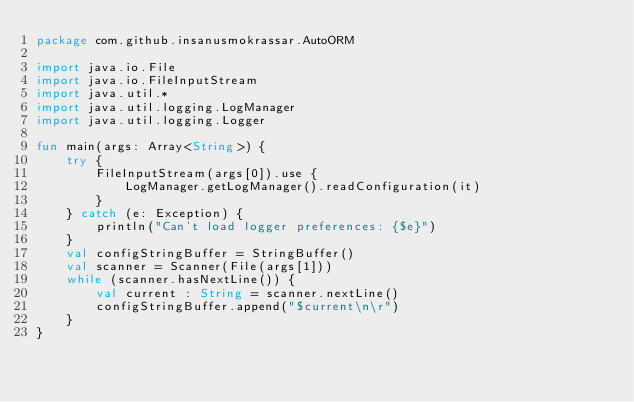Convert code to text. <code><loc_0><loc_0><loc_500><loc_500><_Kotlin_>package com.github.insanusmokrassar.AutoORM

import java.io.File
import java.io.FileInputStream
import java.util.*
import java.util.logging.LogManager
import java.util.logging.Logger

fun main(args: Array<String>) {
    try {
        FileInputStream(args[0]).use {
            LogManager.getLogManager().readConfiguration(it)
        }
    } catch (e: Exception) {
        println("Can't load logger preferences: {$e}")
    }
    val configStringBuffer = StringBuffer()
    val scanner = Scanner(File(args[1]))
    while (scanner.hasNextLine()) {
        val current : String = scanner.nextLine()
        configStringBuffer.append("$current\n\r")
    }
}
</code> 